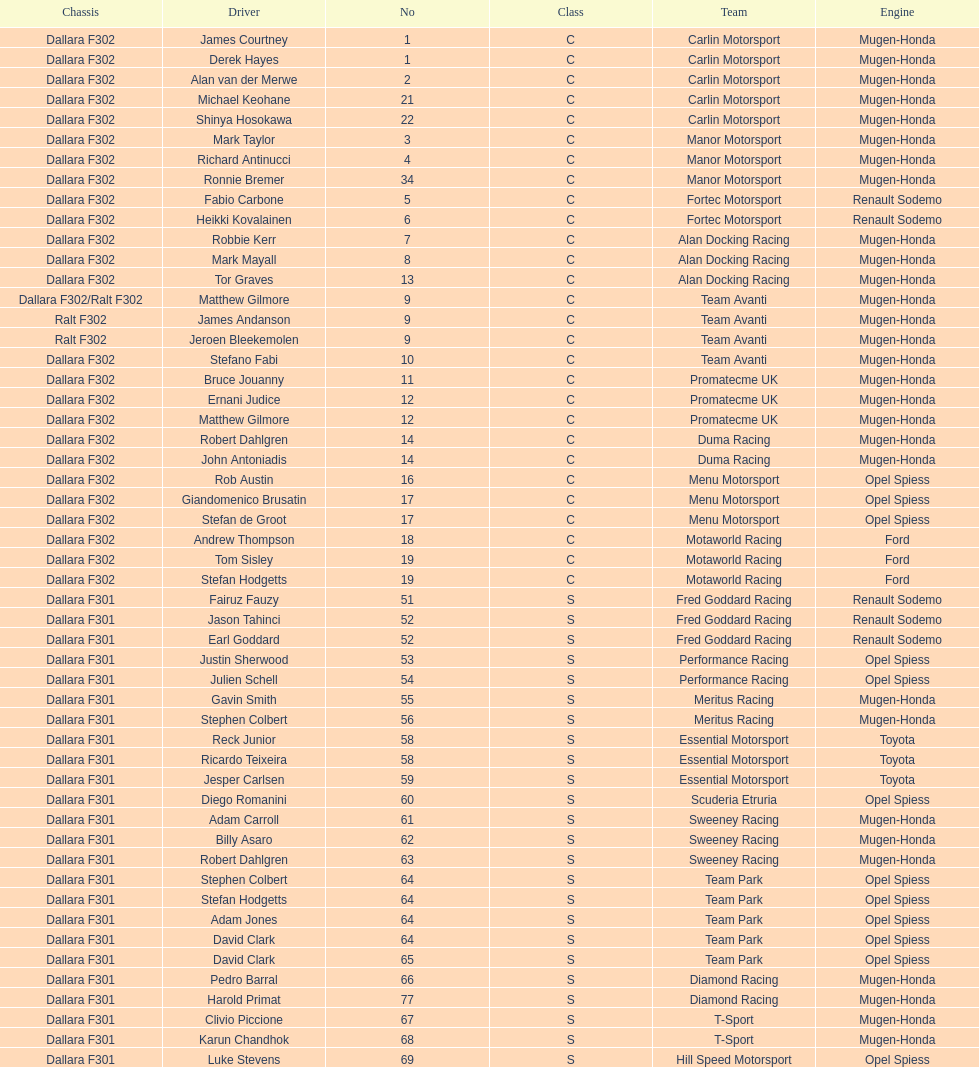What is the average number of teams that had a mugen-honda engine? 24. 